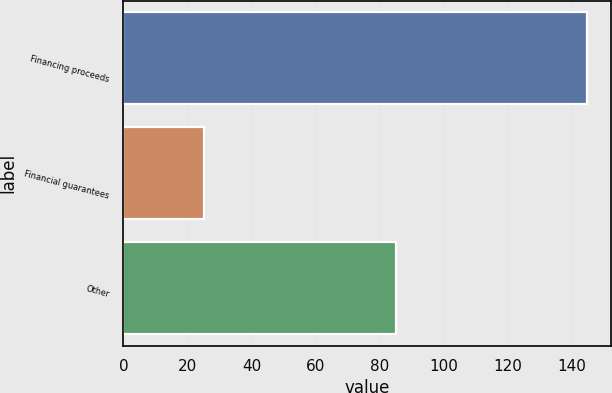Convert chart. <chart><loc_0><loc_0><loc_500><loc_500><bar_chart><fcel>Financing proceeds<fcel>Financial guarantees<fcel>Other<nl><fcel>144.9<fcel>25.3<fcel>85.1<nl></chart> 